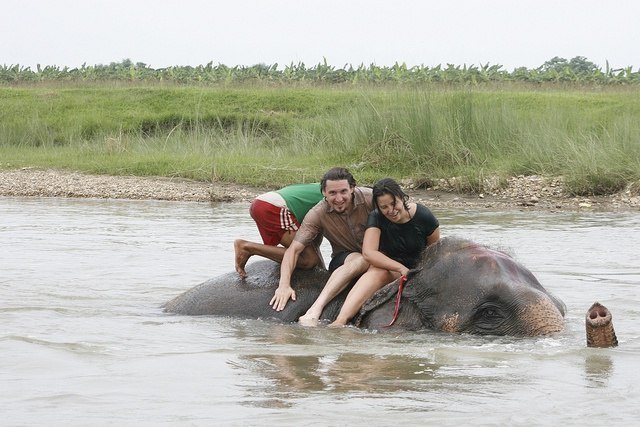Describe the objects in this image and their specific colors. I can see elephant in white, gray, darkgray, and black tones, people in white, gray, black, maroon, and tan tones, people in white, black, tan, and gray tones, and people in white, maroon, brown, and black tones in this image. 